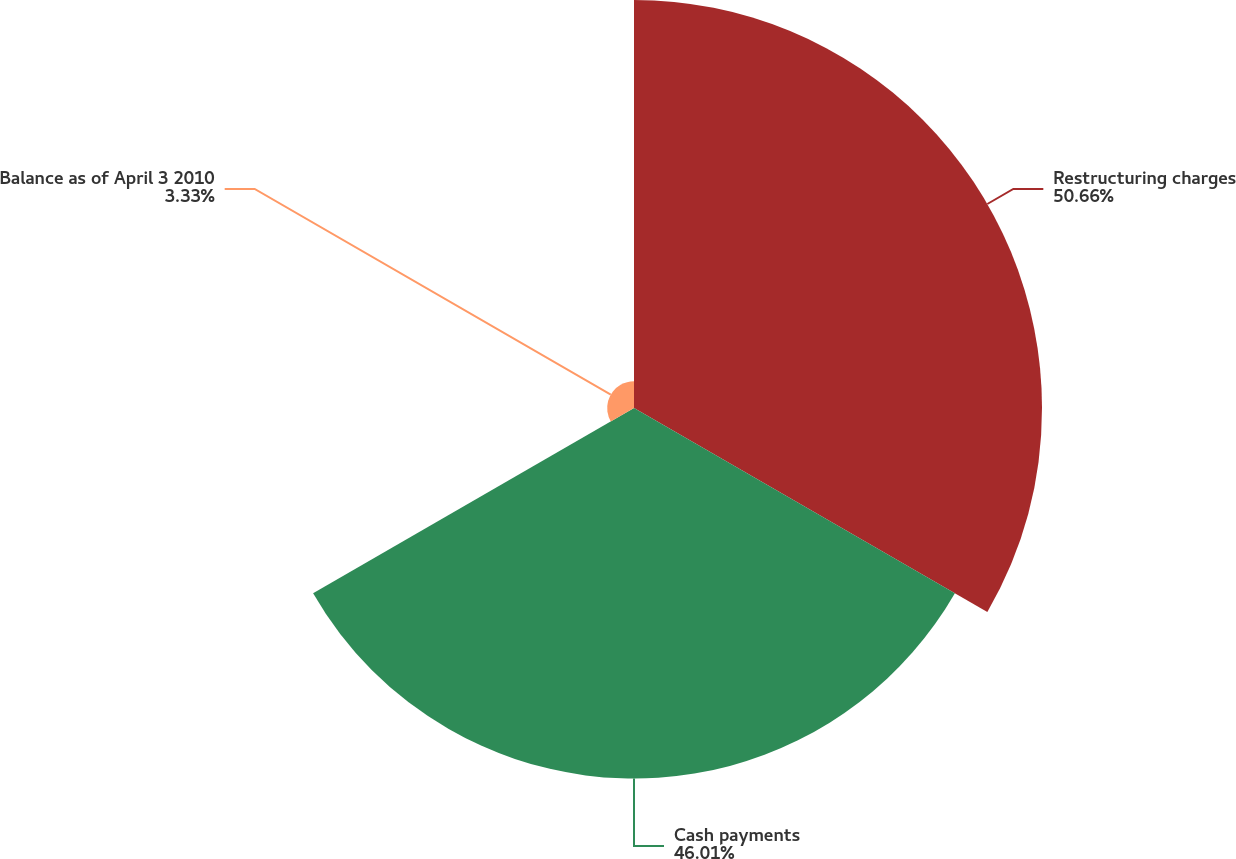Convert chart to OTSL. <chart><loc_0><loc_0><loc_500><loc_500><pie_chart><fcel>Restructuring charges<fcel>Cash payments<fcel>Balance as of April 3 2010<nl><fcel>50.66%<fcel>46.01%<fcel>3.33%<nl></chart> 